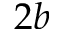Convert formula to latex. <formula><loc_0><loc_0><loc_500><loc_500>2 b</formula> 